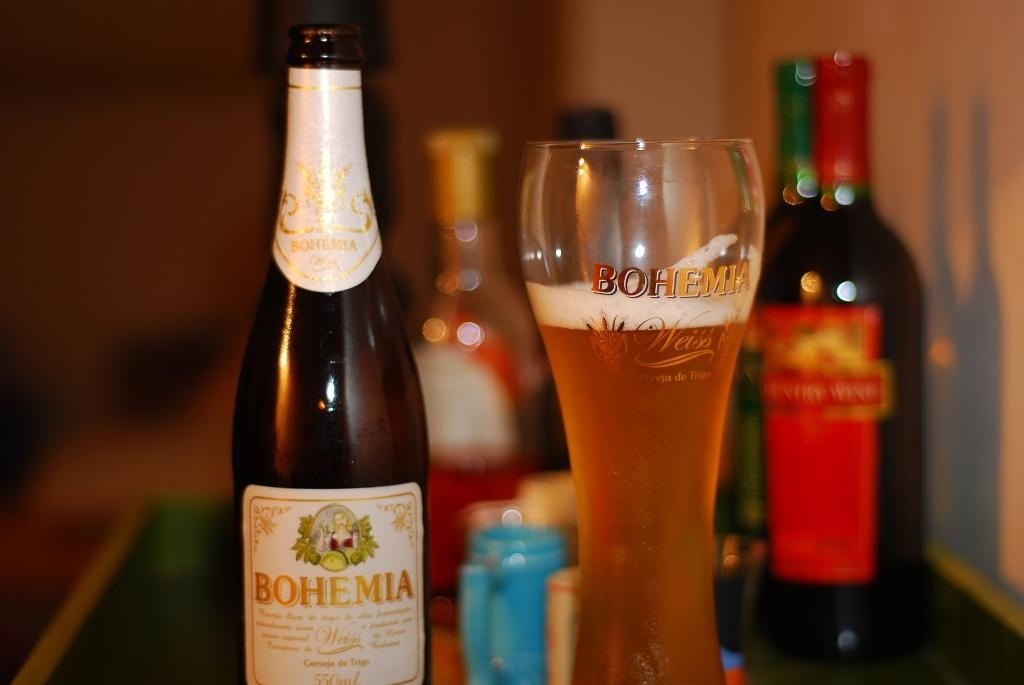<image>
Write a terse but informative summary of the picture. A bottle of Bohemia beer is next to a full glass of beer. 